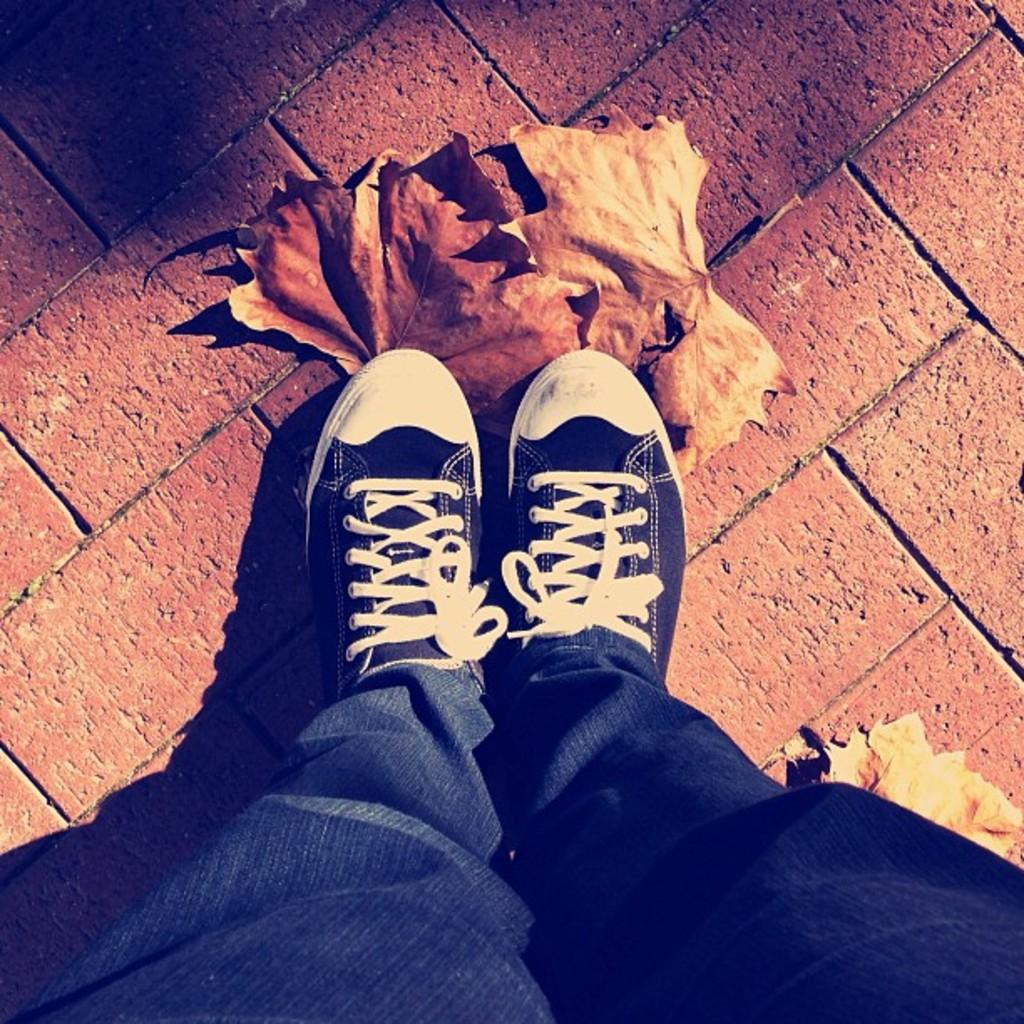What is the main focus of the image? The main focus of the image is the legs of a person. What type of vegetation can be seen in the image? Leaves are visible in the image. What is the surface on which the person is standing? There is a ground in the image. What type of canvas is being used by the army in the image? There is no canvas or army present in the image; it only features the legs of a person and leaves. How many cups can be seen in the image? There are no cups present in the image. 